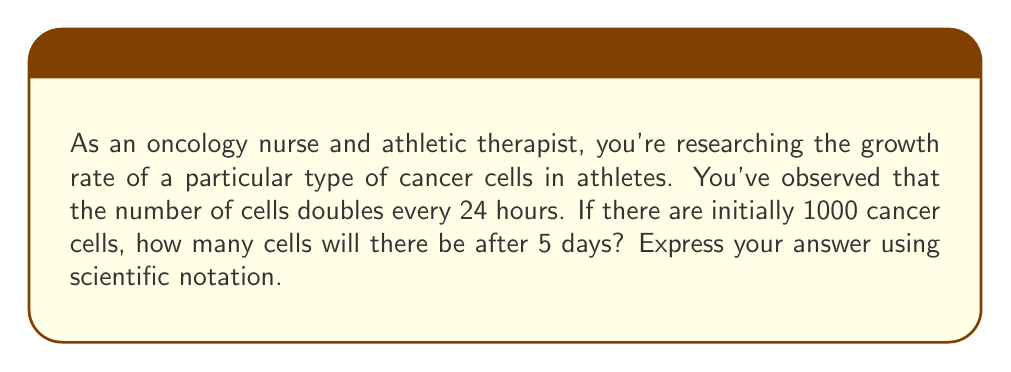Give your solution to this math problem. Let's approach this step-by-step:

1) First, we need to identify the exponential growth function. The general form is:

   $$ A(t) = A_0 \cdot b^t $$

   Where $A(t)$ is the amount after time $t$, $A_0$ is the initial amount, $b$ is the growth factor, and $t$ is the time.

2) We know:
   - Initial amount, $A_0 = 1000$ cells
   - The number of cells doubles every 24 hours, so $b = 2$
   - Time, $t = 5$ days

3) However, our growth factor is per day, and we're looking at 5 days. So our equation becomes:

   $$ A(5) = 1000 \cdot 2^5 $$

4) Now, let's calculate:

   $$ A(5) = 1000 \cdot 2^5 = 1000 \cdot 32 = 32000 $$

5) To express this in scientific notation, we move the decimal point to the left until we have a number between 1 and 10, and then count how many places we moved:

   $32000 = 3.2 \times 10^4$

Thus, after 5 days, there will be $3.2 \times 10^4$ cancer cells.
Answer: $3.2 \times 10^4$ cells 